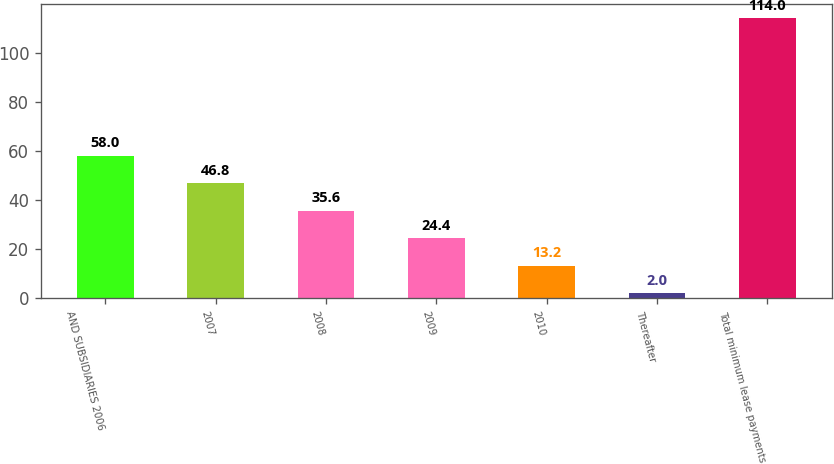Convert chart. <chart><loc_0><loc_0><loc_500><loc_500><bar_chart><fcel>AND SUBSIDIARIES 2006<fcel>2007<fcel>2008<fcel>2009<fcel>2010<fcel>Thereafter<fcel>Total minimum lease payments<nl><fcel>58<fcel>46.8<fcel>35.6<fcel>24.4<fcel>13.2<fcel>2<fcel>114<nl></chart> 